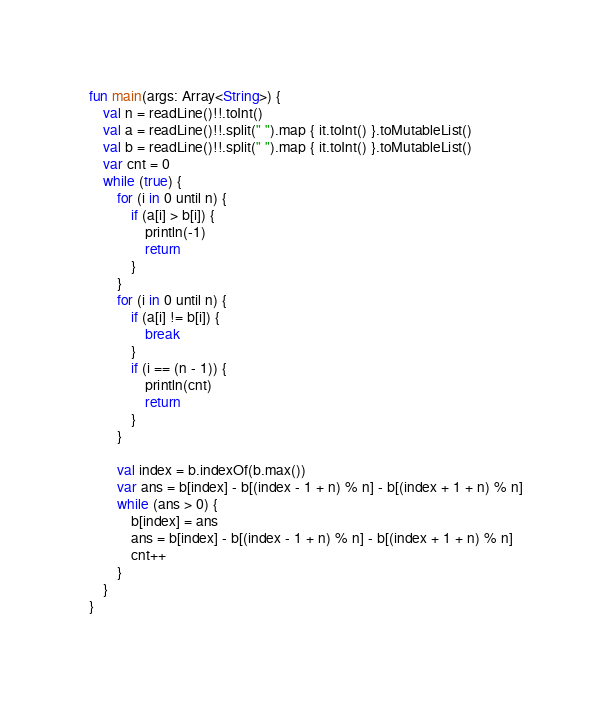<code> <loc_0><loc_0><loc_500><loc_500><_Kotlin_>fun main(args: Array<String>) {
    val n = readLine()!!.toInt()
    val a = readLine()!!.split(" ").map { it.toInt() }.toMutableList()
    val b = readLine()!!.split(" ").map { it.toInt() }.toMutableList()
    var cnt = 0
    while (true) {
        for (i in 0 until n) {
            if (a[i] > b[i]) {
                println(-1)
                return
            }
        }
        for (i in 0 until n) {
            if (a[i] != b[i]) {
                break
            }
            if (i == (n - 1)) {
                println(cnt)
                return
            }
        }

        val index = b.indexOf(b.max())
        var ans = b[index] - b[(index - 1 + n) % n] - b[(index + 1 + n) % n]
        while (ans > 0) {
            b[index] = ans
            ans = b[index] - b[(index - 1 + n) % n] - b[(index + 1 + n) % n]
            cnt++
        }
    }
}</code> 